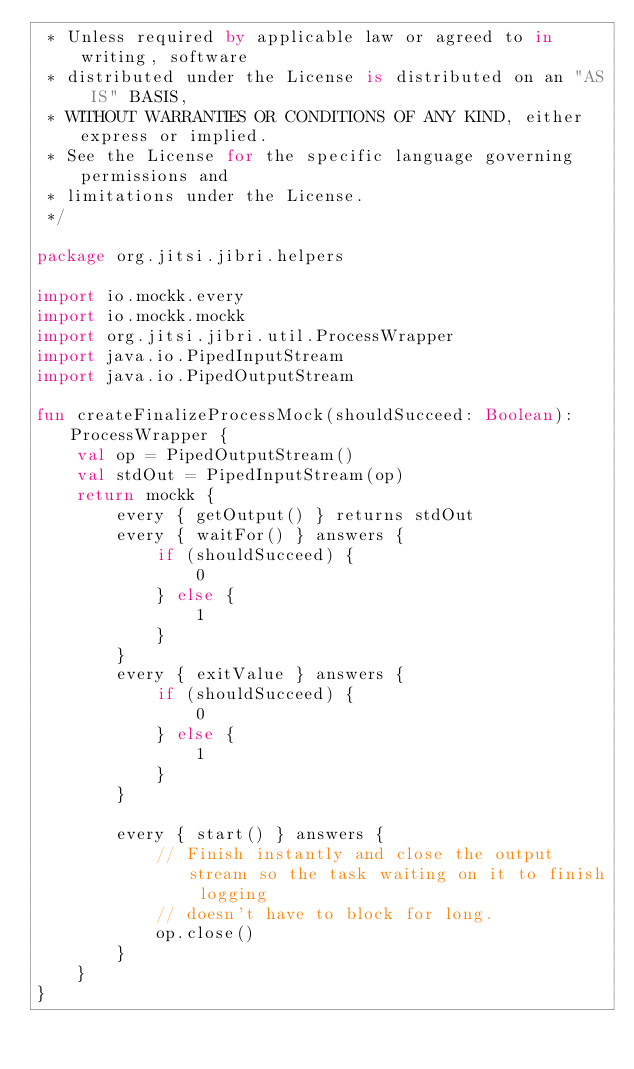<code> <loc_0><loc_0><loc_500><loc_500><_Kotlin_> * Unless required by applicable law or agreed to in writing, software
 * distributed under the License is distributed on an "AS IS" BASIS,
 * WITHOUT WARRANTIES OR CONDITIONS OF ANY KIND, either express or implied.
 * See the License for the specific language governing permissions and
 * limitations under the License.
 */

package org.jitsi.jibri.helpers

import io.mockk.every
import io.mockk.mockk
import org.jitsi.jibri.util.ProcessWrapper
import java.io.PipedInputStream
import java.io.PipedOutputStream

fun createFinalizeProcessMock(shouldSucceed: Boolean): ProcessWrapper {
    val op = PipedOutputStream()
    val stdOut = PipedInputStream(op)
    return mockk {
        every { getOutput() } returns stdOut
        every { waitFor() } answers {
            if (shouldSucceed) {
                0
            } else {
                1
            }
        }
        every { exitValue } answers {
            if (shouldSucceed) {
                0
            } else {
                1
            }
        }

        every { start() } answers {
            // Finish instantly and close the output stream so the task waiting on it to finish logging
            // doesn't have to block for long.
            op.close()
        }
    }
}
</code> 